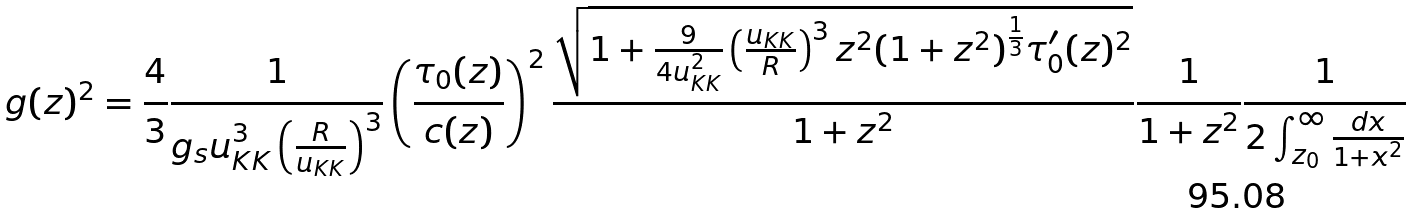<formula> <loc_0><loc_0><loc_500><loc_500>g ( z ) ^ { 2 } = \frac { 4 } { 3 } \frac { 1 } { g _ { s } u _ { K K } ^ { 3 } \left ( \frac { R } { u _ { K K } } \right ) ^ { 3 } } \left ( \frac { \tau _ { 0 } ( z ) } { c ( z ) } \right ) ^ { 2 } \frac { \sqrt { 1 + \frac { 9 } { 4 u _ { K K } ^ { 2 } } \left ( \frac { u _ { K K } } { R } \right ) ^ { 3 } z ^ { 2 } ( 1 + z ^ { 2 } ) ^ { \frac { 1 } { 3 } } \tau _ { 0 } ^ { \prime } ( z ) ^ { 2 } } } { 1 + z ^ { 2 } } \frac { 1 } { 1 + z ^ { 2 } } \frac { 1 } { 2 \int _ { z _ { 0 } } ^ { \infty } \frac { d x } { 1 + x ^ { 2 } } }</formula> 